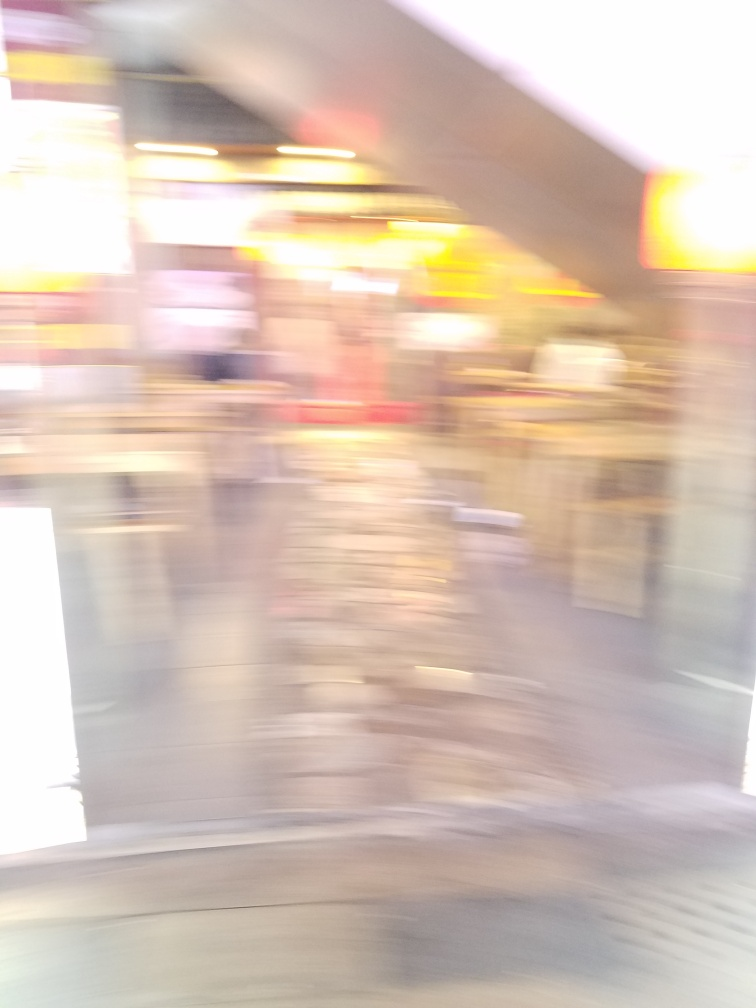Is there a lack of sharpness in the image? Yes, there is a noticeable lack of sharpness in the image, characterized by the blurred lines and the fusion of colors and shapes which prevent clear identification of the elements within the scene. 